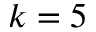Convert formula to latex. <formula><loc_0><loc_0><loc_500><loc_500>k = 5</formula> 